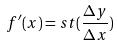<formula> <loc_0><loc_0><loc_500><loc_500>f ^ { \prime } ( x ) = s t ( \frac { \Delta y } { \Delta x } )</formula> 